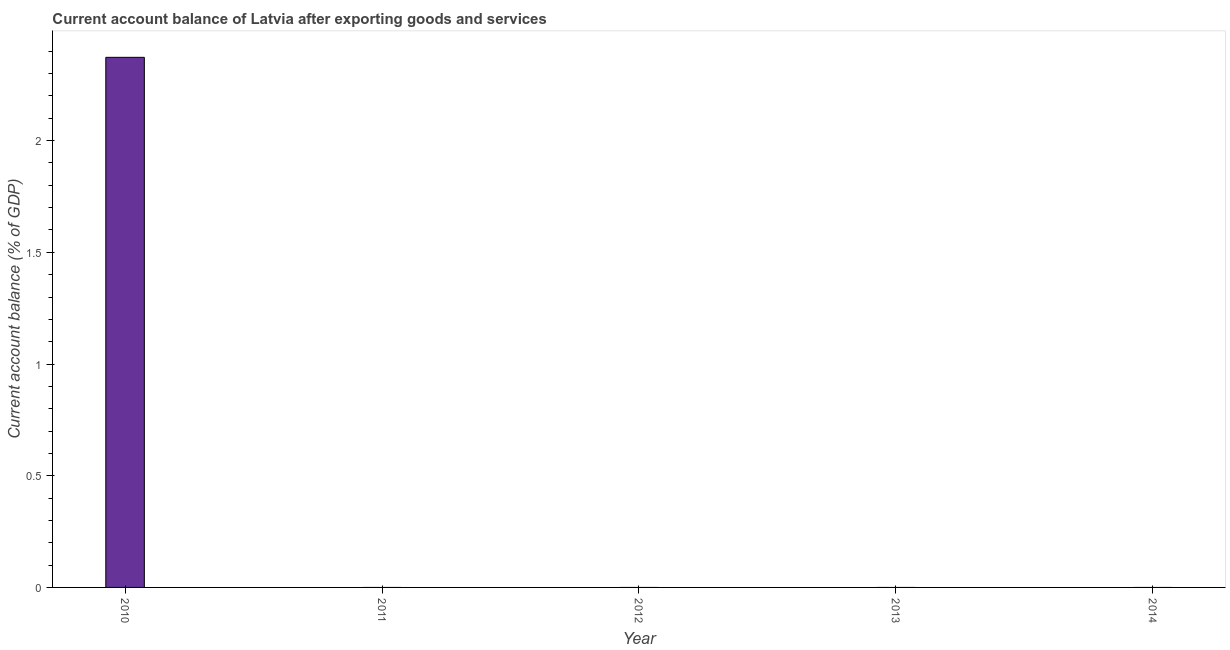Does the graph contain any zero values?
Your answer should be compact. Yes. What is the title of the graph?
Provide a short and direct response. Current account balance of Latvia after exporting goods and services. What is the label or title of the X-axis?
Give a very brief answer. Year. What is the label or title of the Y-axis?
Offer a terse response. Current account balance (% of GDP). What is the current account balance in 2013?
Make the answer very short. 0. Across all years, what is the maximum current account balance?
Keep it short and to the point. 2.37. What is the sum of the current account balance?
Offer a very short reply. 2.37. What is the average current account balance per year?
Your answer should be very brief. 0.47. What is the median current account balance?
Provide a succinct answer. 0. In how many years, is the current account balance greater than 1.1 %?
Your answer should be very brief. 1. What is the difference between the highest and the lowest current account balance?
Give a very brief answer. 2.37. How many bars are there?
Provide a short and direct response. 1. What is the difference between two consecutive major ticks on the Y-axis?
Give a very brief answer. 0.5. What is the Current account balance (% of GDP) in 2010?
Your answer should be compact. 2.37. What is the Current account balance (% of GDP) in 2012?
Offer a terse response. 0. What is the Current account balance (% of GDP) in 2014?
Offer a terse response. 0. 